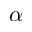<formula> <loc_0><loc_0><loc_500><loc_500>\alpha</formula> 